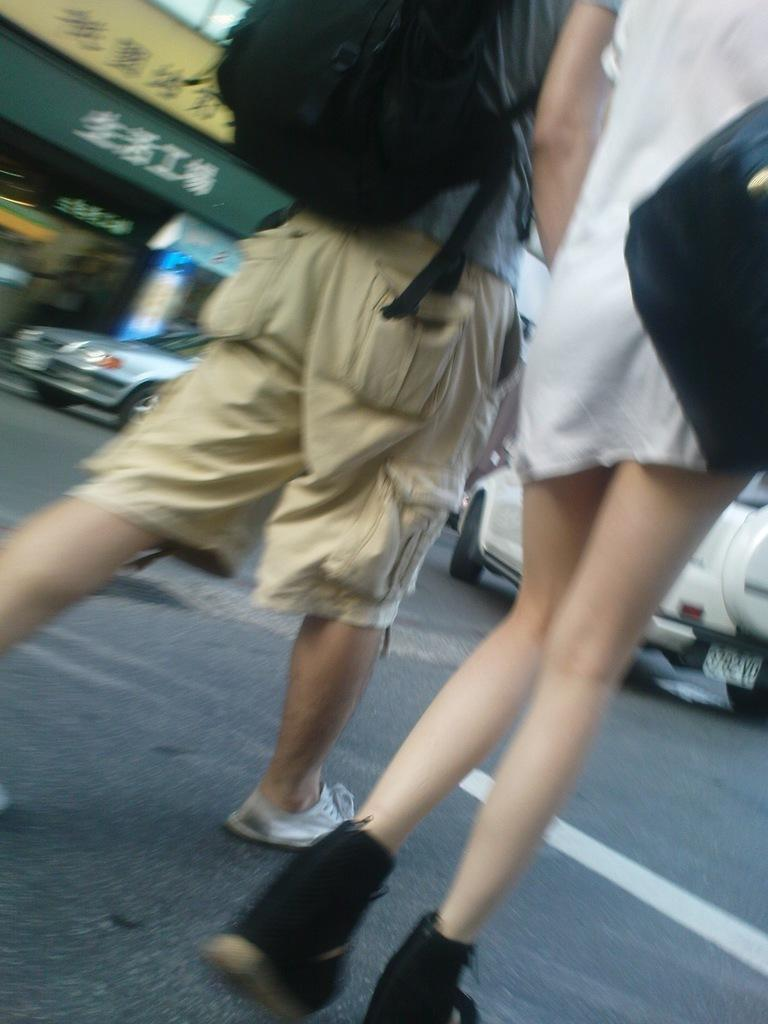How many people are present in the image? There are two people, a man and a woman, present in the image. What are the man and woman wearing? Both the man and woman are wearing bags. What are they doing in the image? They are walking on a road. What can be seen in the background of the image? There are vehicles and at least one building in the background of the image. What type of wine is being served at the camp in the image? There is no camp or wine present in the image; it features a man and a woman walking on a road with vehicles and buildings in the background. 